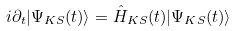<formula> <loc_0><loc_0><loc_500><loc_500>i \partial _ { t } | \Psi _ { K S } ( t ) \rangle = \hat { H } _ { K S } ( t ) | \Psi _ { K S } ( t ) \rangle</formula> 